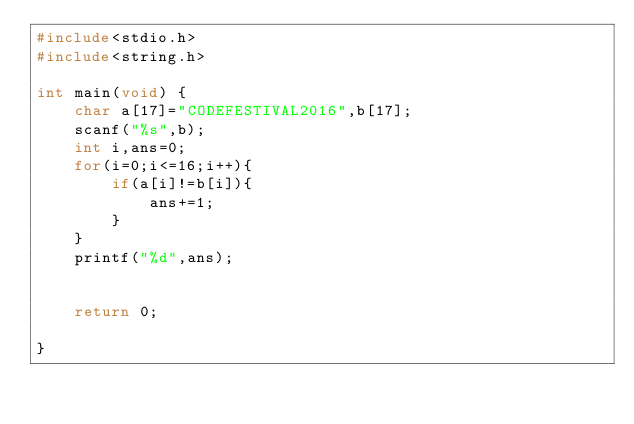<code> <loc_0><loc_0><loc_500><loc_500><_C_>#include<stdio.h>
#include<string.h>

int main(void) {
    char a[17]="CODEFESTIVAL2016",b[17];
    scanf("%s",b);
    int i,ans=0;
    for(i=0;i<=16;i++){
        if(a[i]!=b[i]){
            ans+=1;
        }
    }
    printf("%d",ans);
    
    
    return 0;
    
}
</code> 